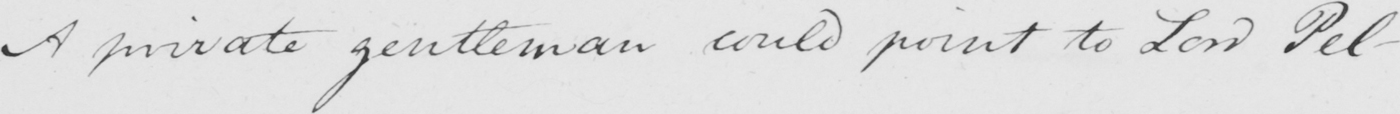What text is written in this handwritten line? A private gentleman could point to Lord Pel- 